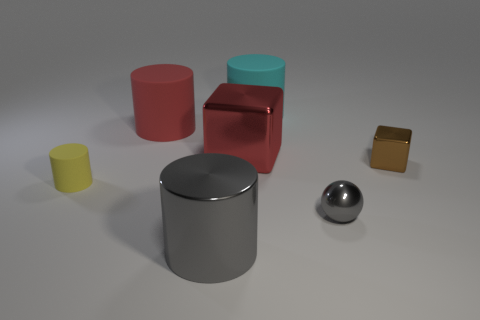Add 2 yellow blocks. How many objects exist? 9 Subtract all large metallic cylinders. How many cylinders are left? 3 Subtract all blocks. How many objects are left? 5 Add 7 tiny metallic spheres. How many tiny metallic spheres exist? 8 Subtract all gray cylinders. How many cylinders are left? 3 Subtract 0 green balls. How many objects are left? 7 Subtract all green blocks. Subtract all brown spheres. How many blocks are left? 2 Subtract all blue spheres. How many green cubes are left? 0 Subtract all big gray balls. Subtract all large matte cylinders. How many objects are left? 5 Add 2 red objects. How many red objects are left? 4 